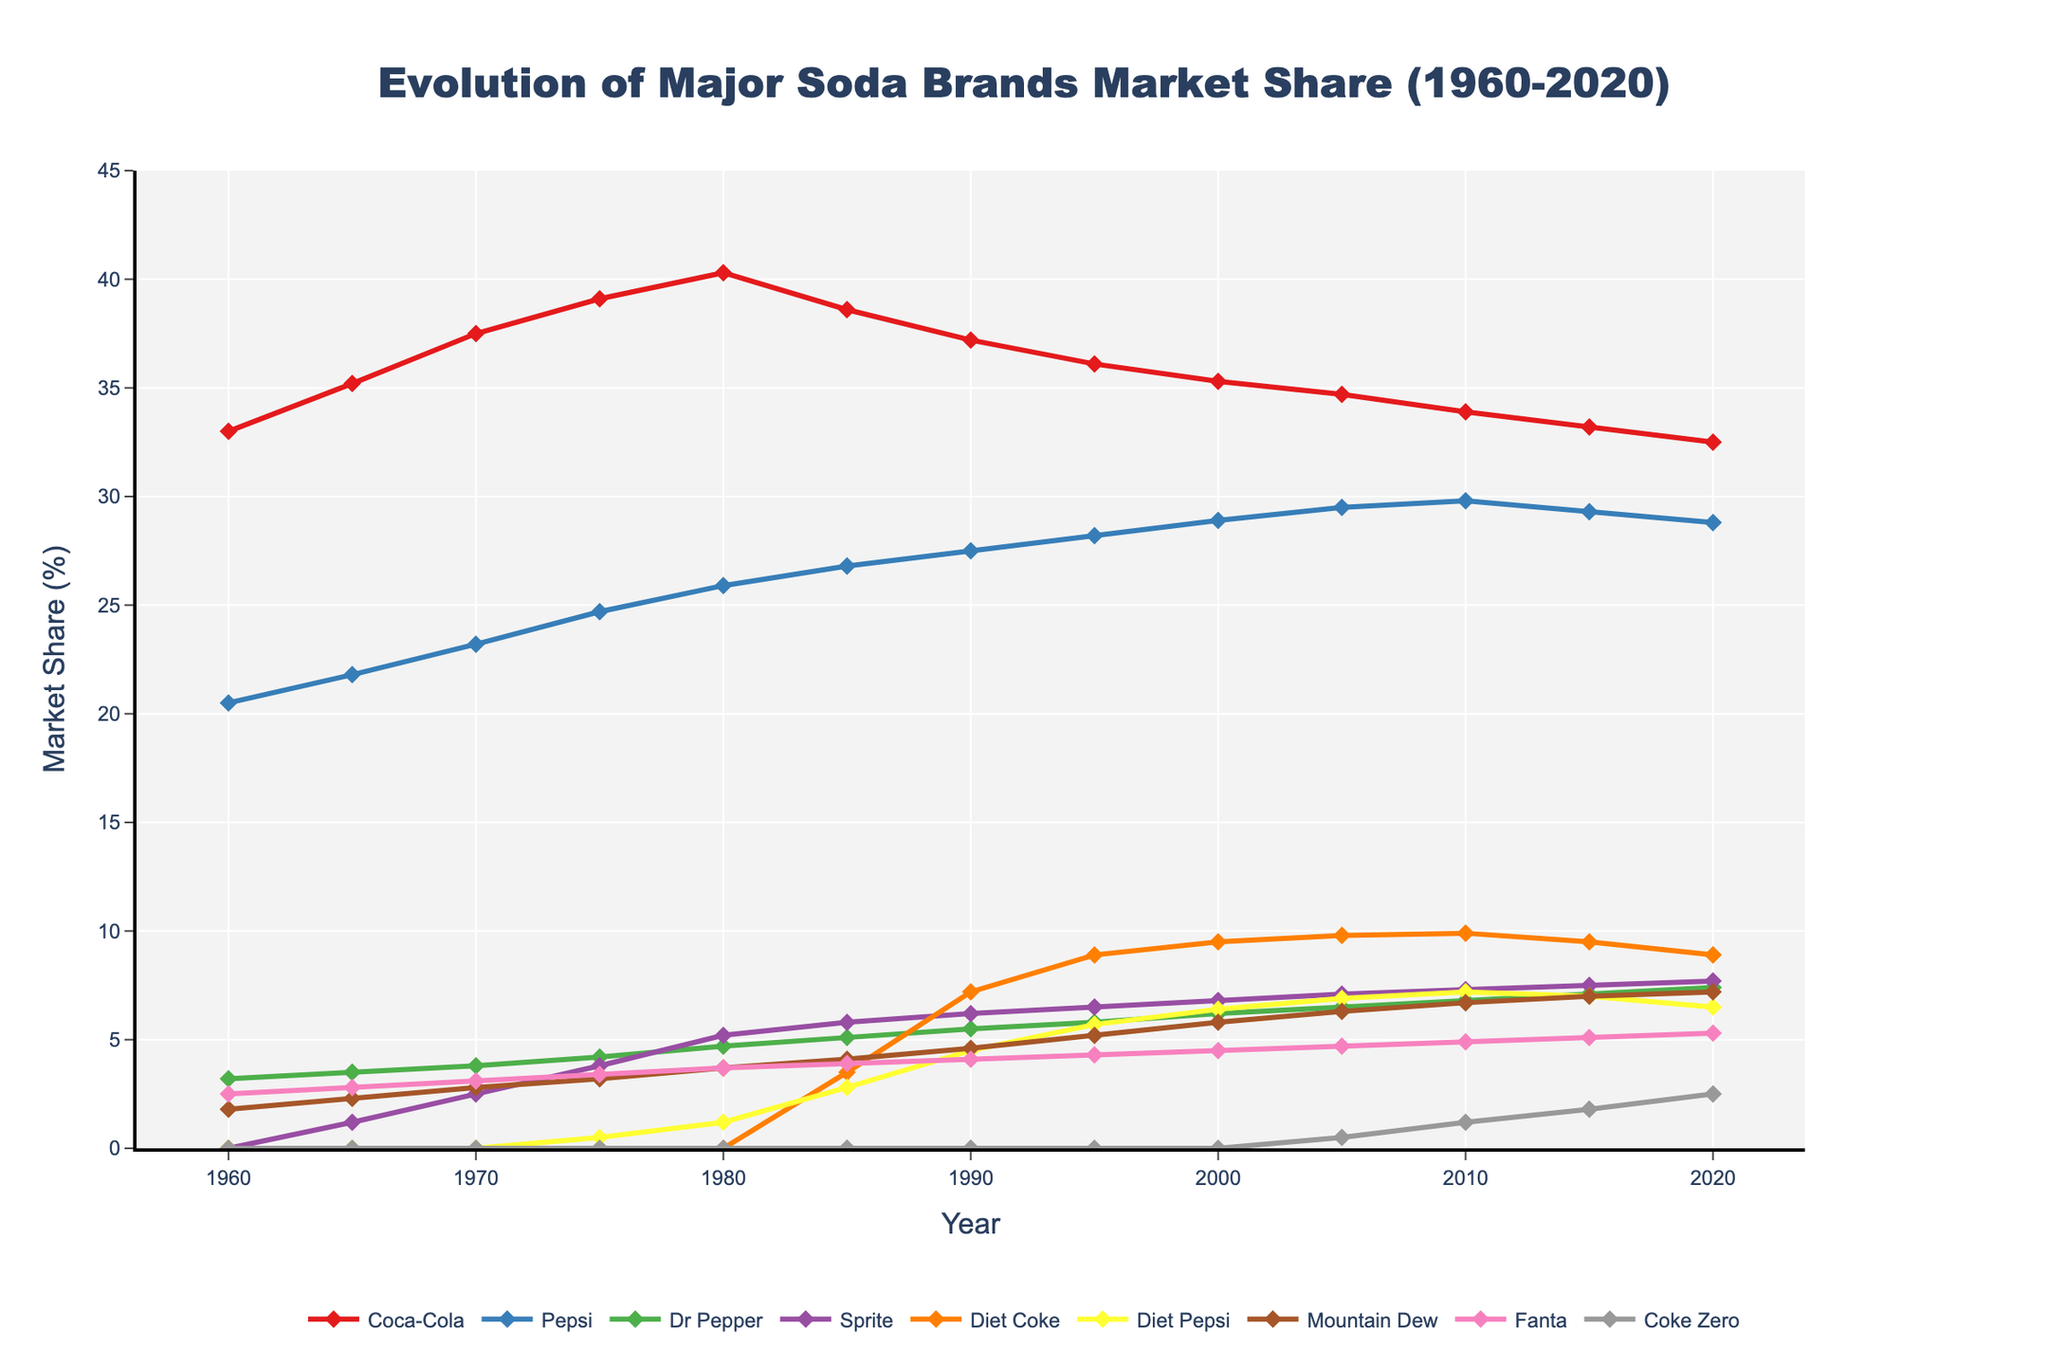How did Coca-Cola's market share change between 1960 and 1990? Coca-Cola's market share in 1960 was 33.0%. In 1990, it was 37.2%. The change in market share is 37.2% - 33.0% = 4.2%.
Answer: Increased by 4.2% Which brand had the highest market share in 2020? By comparing the market share values of all brands in 2020, Coca-Cola has the highest market share at 32.5%.
Answer: Coca-Cola How does the market share of Diet Coke in 2020 compare to its peak value? The peak value of Diet Coke's market share was 9.9% in 2010. In 2020, it is 8.9%. The difference is 9.9% - 8.9% = 1%.
Answer: 1% lower What is the average market share of Pepsi from 1960 to 2020? Sum of Pepsi's market shares over the years (20.5 + 21.8 + 23.2 + 24.7 + 25.9 + 26.8 + 27.5 + 28.2 + 28.9 + 29.5 + 29.8 + 29.3 + 28.8) = 345, divided by the number of years (13), results in an average market share of 345 / 13 ≈ 26.54%.
Answer: 26.54% Which diet soda has consistently higher market share since 1985, Diet Coke or Diet Pepsi? From 1985 onward: 3.5%, 7.2%, 8.9%, 9.5%, 9.8%, 9.9%, 9.5%, 8.9% for Diet Coke and 2.8%, 4.5%, 5.7%, 6.4%, 6.9%, 7.2%, 7.0%, 6.5% for Diet Pepsi. Diet Coke has consistently higher market share in each year.
Answer: Diet Coke Between which years did Sprite experience the most significant growth in market share? Compare the changes in market share across years. The largest increase is from 1975 (3.8%) to 1980 (5.2%), which is 5.2% - 3.8% = 1.4%.
Answer: 1975 to 1980 What is the difference in market share between Mountain Dew and Dr Pepper in 2000? In 2000, the market shares were 5.8% for Mountain Dew and 6.2% for Dr Pepper. The difference is 6.2% - 5.8% = 0.4%.
Answer: 0.4% Has Fanta's market share increased or decreased from 1960 to 2020? In 1960, Fanta's market share was 2.5%. In 2020, it is 5.3%. The increase is 5.3% - 2.5% = 2.8%.
Answer: Increased by 2.8% How does the rise of low-sugar varieties (Diet Coke, Diet Pepsi, Coke Zero) impact market shares of regular sodas (Coca-Cola, Pepsi, Dr Pepper)? Compared market share: Coca-Cola from 40.3% in 1980 to 32.5% in 2020; Pepsi from 25.9% in 1980 to 28.8% in 2020; Dr Pepper from 4.7% in 1980 to 7.4% in 2020. Diet sodas gained share as regular sodas saw mixed results.
Answer: Varies, regular Coca-Cola decreased What was the total market share of all brands in the provided year data for 2020? Sum all market shares for 2020: 32.5% + 28.8% + 7.4% + 7.7% + 8.9% + 6.5% + 7.2% + 5.3% + 2.5% = 106.8%.
Answer: 106.8% 